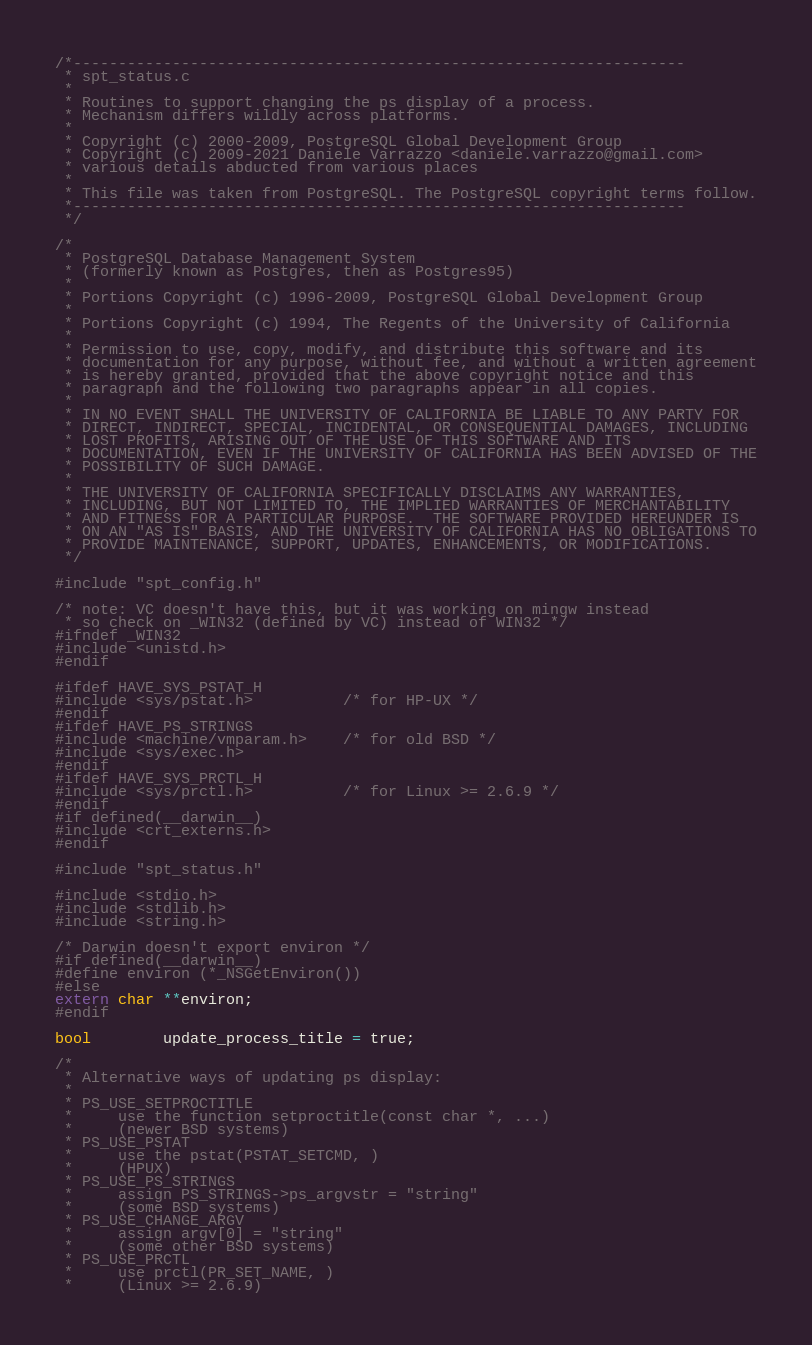Convert code to text. <code><loc_0><loc_0><loc_500><loc_500><_C_>/*--------------------------------------------------------------------
 * spt_status.c
 *
 * Routines to support changing the ps display of a process.
 * Mechanism differs wildly across platforms.
 *
 * Copyright (c) 2000-2009, PostgreSQL Global Development Group
 * Copyright (c) 2009-2021 Daniele Varrazzo <daniele.varrazzo@gmail.com>
 * various details abducted from various places
 *
 * This file was taken from PostgreSQL. The PostgreSQL copyright terms follow.
 *--------------------------------------------------------------------
 */

/*
 * PostgreSQL Database Management System
 * (formerly known as Postgres, then as Postgres95)
 *
 * Portions Copyright (c) 1996-2009, PostgreSQL Global Development Group
 *
 * Portions Copyright (c) 1994, The Regents of the University of California
 *
 * Permission to use, copy, modify, and distribute this software and its
 * documentation for any purpose, without fee, and without a written agreement
 * is hereby granted, provided that the above copyright notice and this
 * paragraph and the following two paragraphs appear in all copies.
 *
 * IN NO EVENT SHALL THE UNIVERSITY OF CALIFORNIA BE LIABLE TO ANY PARTY FOR
 * DIRECT, INDIRECT, SPECIAL, INCIDENTAL, OR CONSEQUENTIAL DAMAGES, INCLUDING
 * LOST PROFITS, ARISING OUT OF THE USE OF THIS SOFTWARE AND ITS
 * DOCUMENTATION, EVEN IF THE UNIVERSITY OF CALIFORNIA HAS BEEN ADVISED OF THE
 * POSSIBILITY OF SUCH DAMAGE.
 *
 * THE UNIVERSITY OF CALIFORNIA SPECIFICALLY DISCLAIMS ANY WARRANTIES,
 * INCLUDING, BUT NOT LIMITED TO, THE IMPLIED WARRANTIES OF MERCHANTABILITY
 * AND FITNESS FOR A PARTICULAR PURPOSE.  THE SOFTWARE PROVIDED HEREUNDER IS
 * ON AN "AS IS" BASIS, AND THE UNIVERSITY OF CALIFORNIA HAS NO OBLIGATIONS TO
 * PROVIDE MAINTENANCE, SUPPORT, UPDATES, ENHANCEMENTS, OR MODIFICATIONS.
 */

#include "spt_config.h"

/* note: VC doesn't have this, but it was working on mingw instead
 * so check on _WIN32 (defined by VC) instead of WIN32 */
#ifndef _WIN32
#include <unistd.h>
#endif

#ifdef HAVE_SYS_PSTAT_H
#include <sys/pstat.h>          /* for HP-UX */
#endif
#ifdef HAVE_PS_STRINGS
#include <machine/vmparam.h>    /* for old BSD */
#include <sys/exec.h>
#endif
#ifdef HAVE_SYS_PRCTL_H
#include <sys/prctl.h>          /* for Linux >= 2.6.9 */
#endif
#if defined(__darwin__)
#include <crt_externs.h>
#endif

#include "spt_status.h"

#include <stdio.h>
#include <stdlib.h>
#include <string.h>

/* Darwin doesn't export environ */
#if defined(__darwin__)
#define environ (*_NSGetEnviron())
#else
extern char **environ;
#endif

bool        update_process_title = true;

/*
 * Alternative ways of updating ps display:
 *
 * PS_USE_SETPROCTITLE
 *     use the function setproctitle(const char *, ...)
 *     (newer BSD systems)
 * PS_USE_PSTAT
 *     use the pstat(PSTAT_SETCMD, )
 *     (HPUX)
 * PS_USE_PS_STRINGS
 *     assign PS_STRINGS->ps_argvstr = "string"
 *     (some BSD systems)
 * PS_USE_CHANGE_ARGV
 *     assign argv[0] = "string"
 *     (some other BSD systems)
 * PS_USE_PRCTL
 *     use prctl(PR_SET_NAME, )
 *     (Linux >= 2.6.9)</code> 